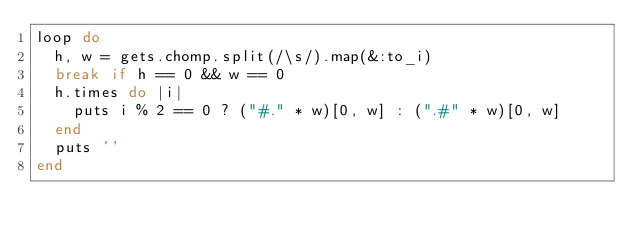<code> <loc_0><loc_0><loc_500><loc_500><_Ruby_>loop do
  h, w = gets.chomp.split(/\s/).map(&:to_i)
  break if h == 0 && w == 0
  h.times do |i|
    puts i % 2 == 0 ? ("#." * w)[0, w] : (".#" * w)[0, w]
  end
  puts ''
end</code> 